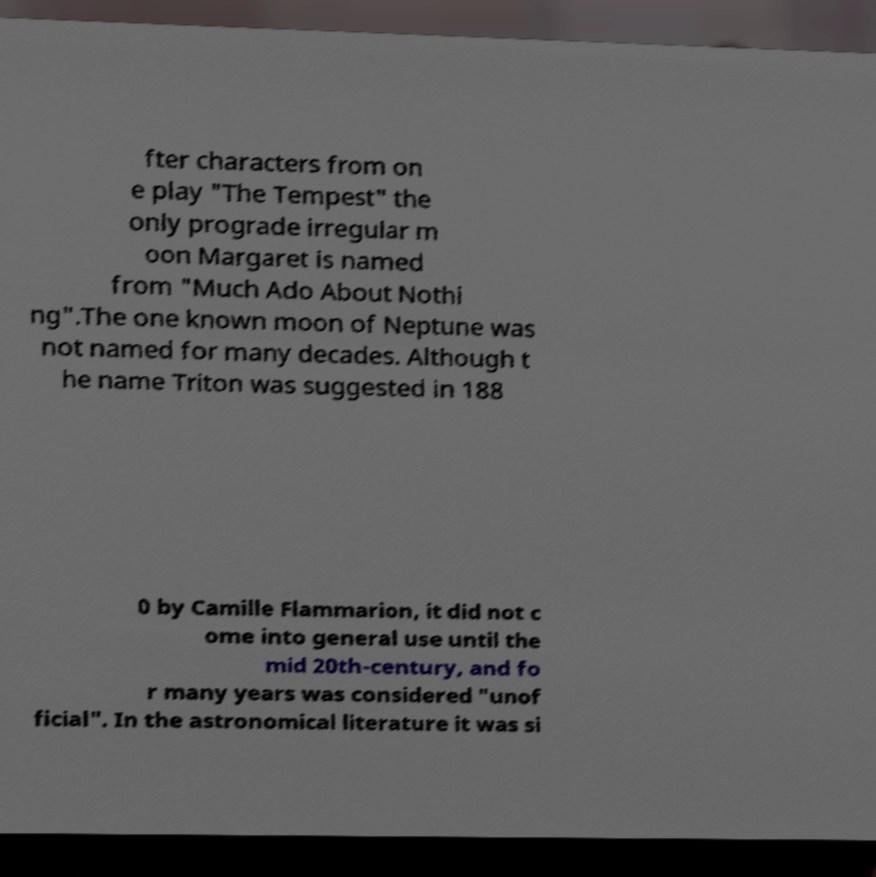Can you read and provide the text displayed in the image?This photo seems to have some interesting text. Can you extract and type it out for me? fter characters from on e play "The Tempest" the only prograde irregular m oon Margaret is named from "Much Ado About Nothi ng".The one known moon of Neptune was not named for many decades. Although t he name Triton was suggested in 188 0 by Camille Flammarion, it did not c ome into general use until the mid 20th-century, and fo r many years was considered "unof ficial". In the astronomical literature it was si 